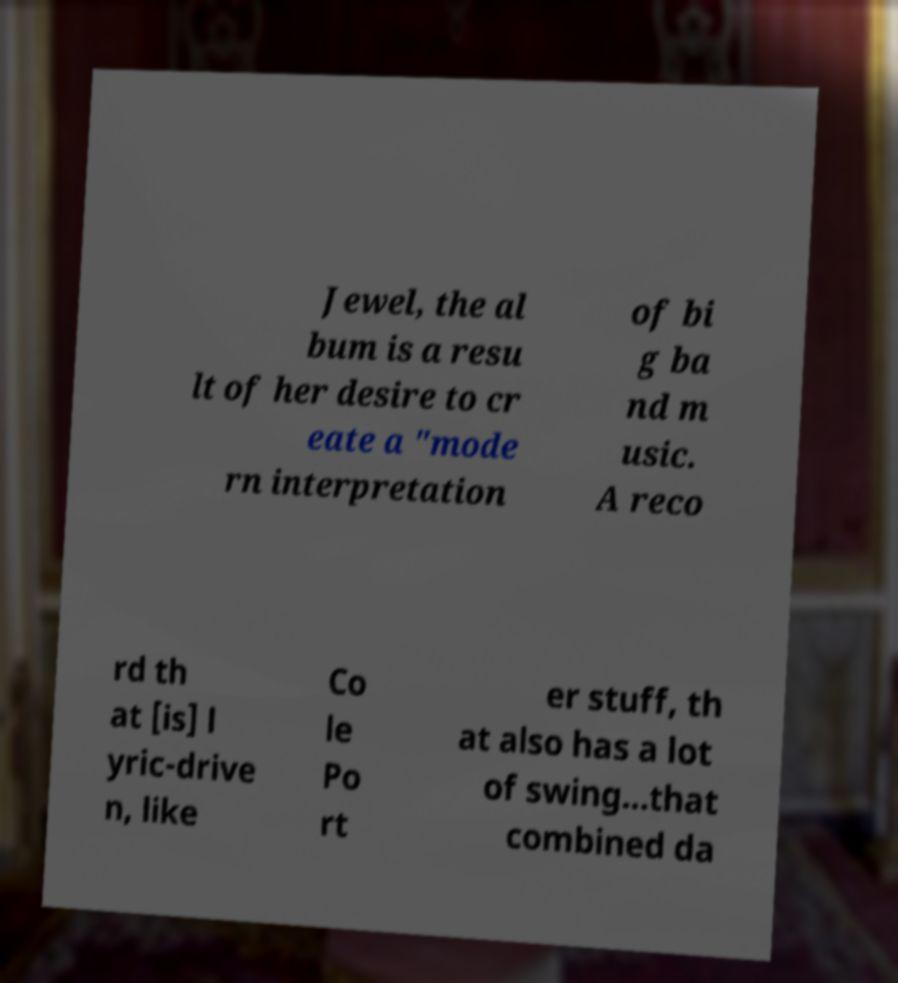Please read and relay the text visible in this image. What does it say? Jewel, the al bum is a resu lt of her desire to cr eate a "mode rn interpretation of bi g ba nd m usic. A reco rd th at [is] l yric-drive n, like Co le Po rt er stuff, th at also has a lot of swing...that combined da 